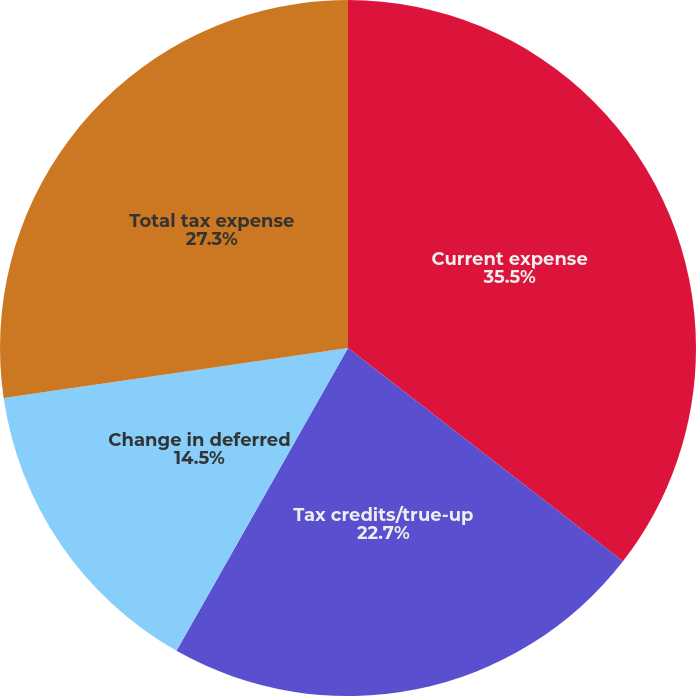Convert chart. <chart><loc_0><loc_0><loc_500><loc_500><pie_chart><fcel>Current expense<fcel>Tax credits/true-up<fcel>Change in deferred<fcel>Total tax expense<nl><fcel>35.5%<fcel>22.7%<fcel>14.5%<fcel>27.3%<nl></chart> 